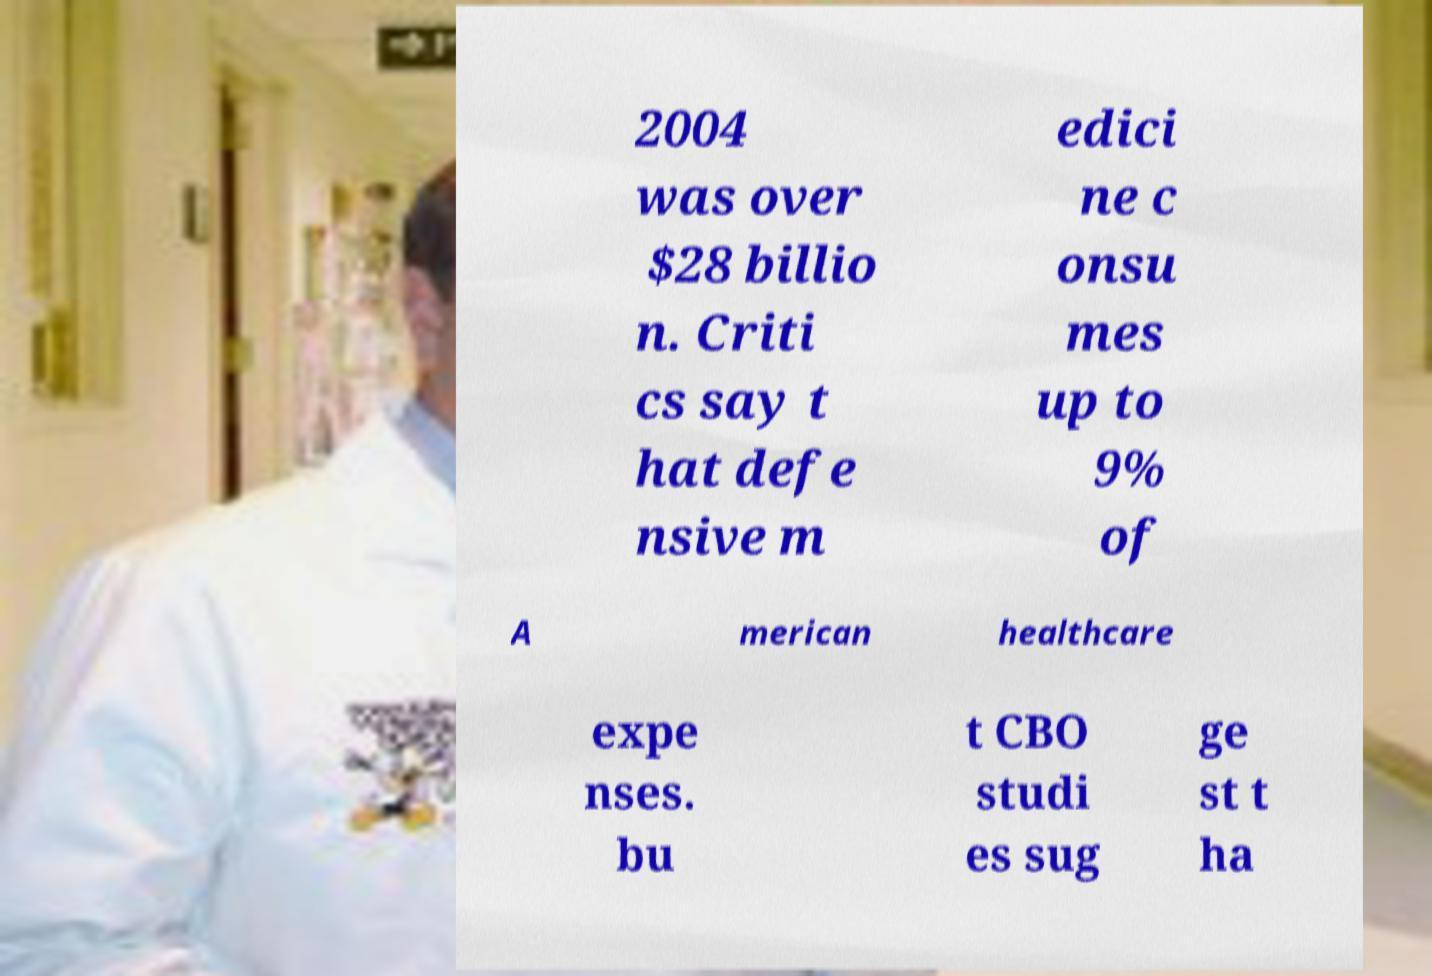Please identify and transcribe the text found in this image. 2004 was over $28 billio n. Criti cs say t hat defe nsive m edici ne c onsu mes up to 9% of A merican healthcare expe nses. bu t CBO studi es sug ge st t ha 